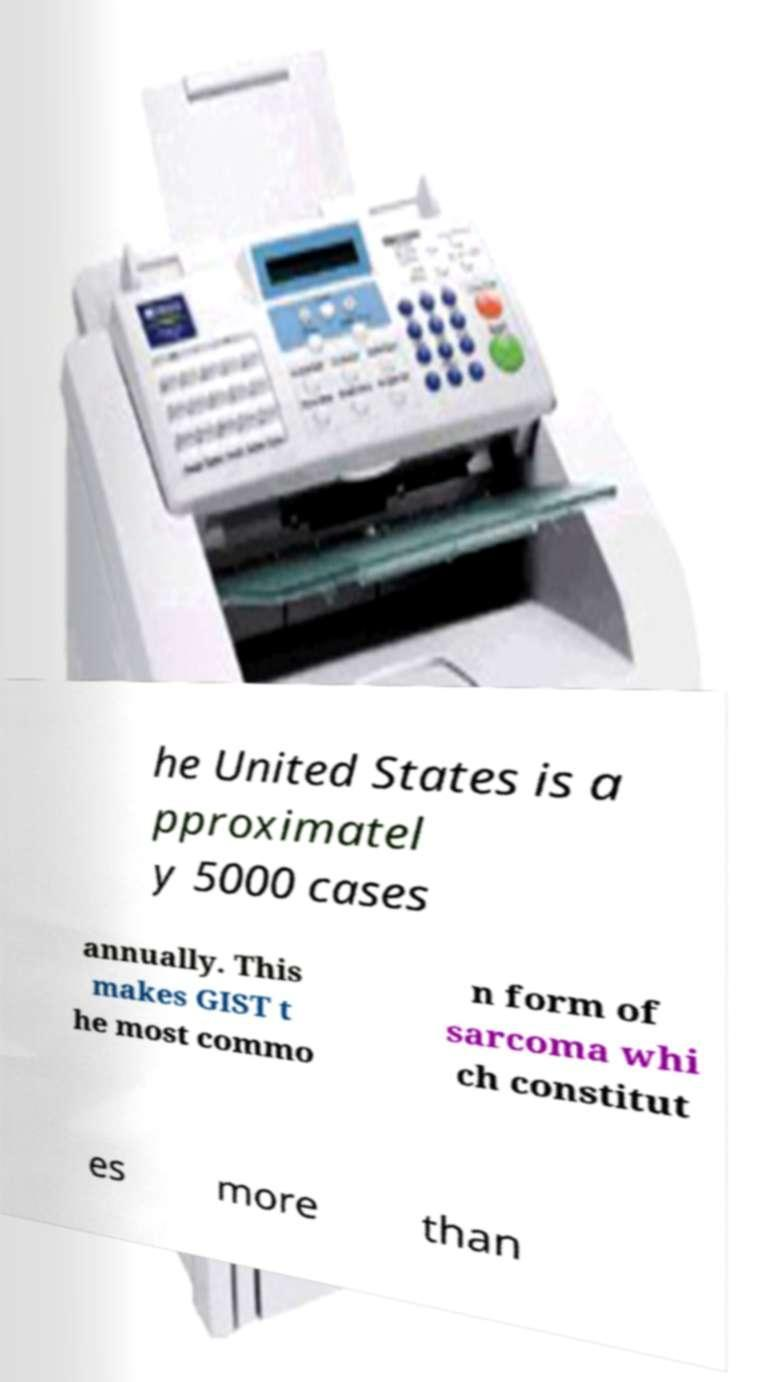Could you assist in decoding the text presented in this image and type it out clearly? he United States is a pproximatel y 5000 cases annually. This makes GIST t he most commo n form of sarcoma whi ch constitut es more than 